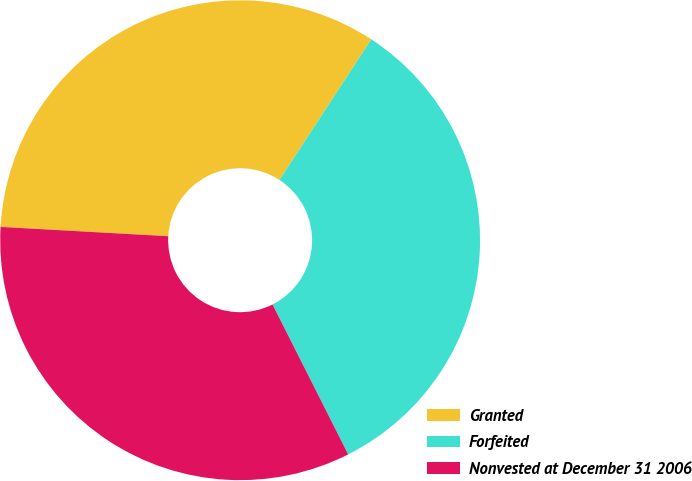Convert chart. <chart><loc_0><loc_0><loc_500><loc_500><pie_chart><fcel>Granted<fcel>Forfeited<fcel>Nonvested at December 31 2006<nl><fcel>33.32%<fcel>33.36%<fcel>33.32%<nl></chart> 